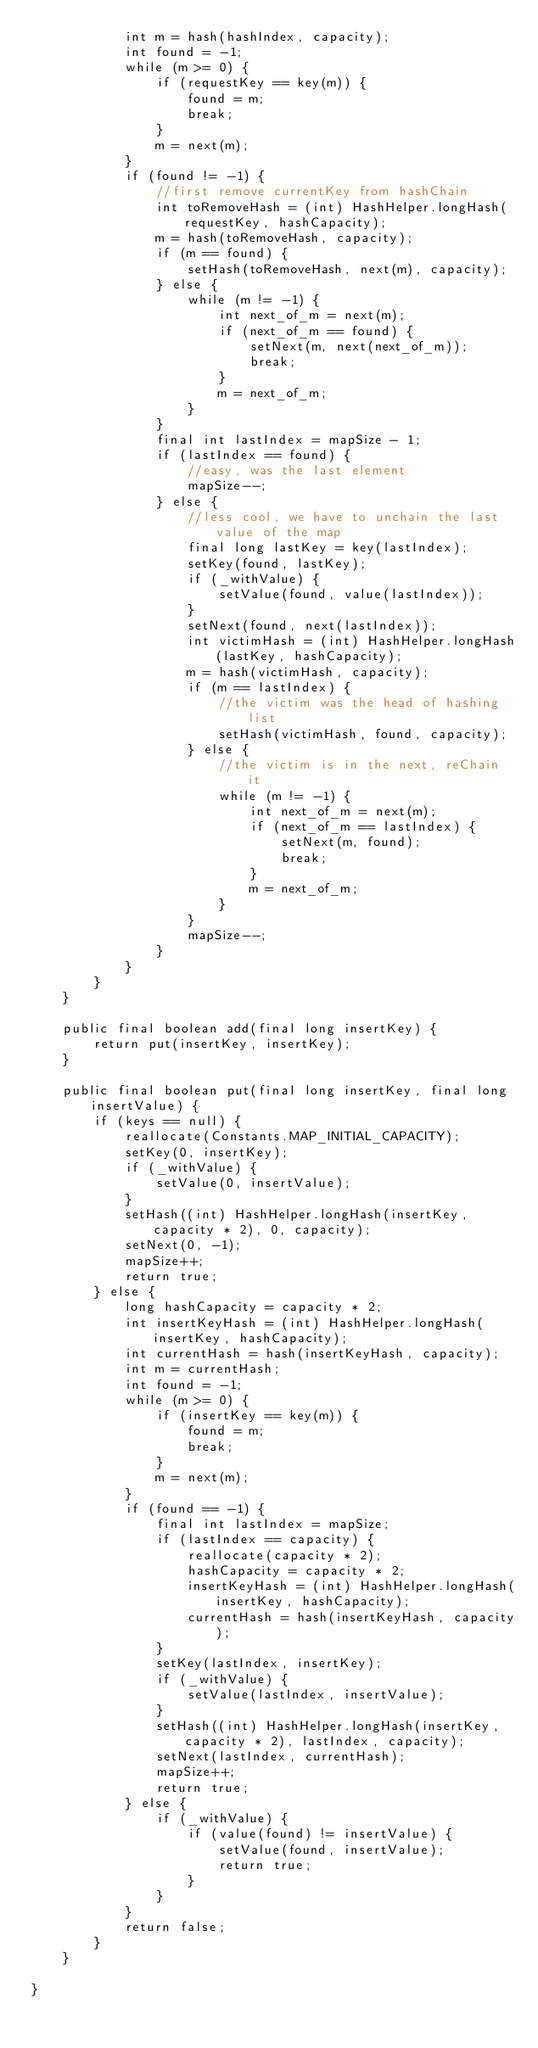<code> <loc_0><loc_0><loc_500><loc_500><_Java_>            int m = hash(hashIndex, capacity);
            int found = -1;
            while (m >= 0) {
                if (requestKey == key(m)) {
                    found = m;
                    break;
                }
                m = next(m);
            }
            if (found != -1) {
                //first remove currentKey from hashChain
                int toRemoveHash = (int) HashHelper.longHash(requestKey, hashCapacity);
                m = hash(toRemoveHash, capacity);
                if (m == found) {
                    setHash(toRemoveHash, next(m), capacity);
                } else {
                    while (m != -1) {
                        int next_of_m = next(m);
                        if (next_of_m == found) {
                            setNext(m, next(next_of_m));
                            break;
                        }
                        m = next_of_m;
                    }
                }
                final int lastIndex = mapSize - 1;
                if (lastIndex == found) {
                    //easy, was the last element
                    mapSize--;
                } else {
                    //less cool, we have to unchain the last value of the map
                    final long lastKey = key(lastIndex);
                    setKey(found, lastKey);
                    if (_withValue) {
                        setValue(found, value(lastIndex));
                    }
                    setNext(found, next(lastIndex));
                    int victimHash = (int) HashHelper.longHash(lastKey, hashCapacity);
                    m = hash(victimHash, capacity);
                    if (m == lastIndex) {
                        //the victim was the head of hashing list
                        setHash(victimHash, found, capacity);
                    } else {
                        //the victim is in the next, reChain it
                        while (m != -1) {
                            int next_of_m = next(m);
                            if (next_of_m == lastIndex) {
                                setNext(m, found);
                                break;
                            }
                            m = next_of_m;
                        }
                    }
                    mapSize--;
                }
            }
        }
    }

    public final boolean add(final long insertKey) {
        return put(insertKey, insertKey);
    }

    public final boolean put(final long insertKey, final long insertValue) {
        if (keys == null) {
            reallocate(Constants.MAP_INITIAL_CAPACITY);
            setKey(0, insertKey);
            if (_withValue) {
                setValue(0, insertValue);
            }
            setHash((int) HashHelper.longHash(insertKey, capacity * 2), 0, capacity);
            setNext(0, -1);
            mapSize++;
            return true;
        } else {
            long hashCapacity = capacity * 2;
            int insertKeyHash = (int) HashHelper.longHash(insertKey, hashCapacity);
            int currentHash = hash(insertKeyHash, capacity);
            int m = currentHash;
            int found = -1;
            while (m >= 0) {
                if (insertKey == key(m)) {
                    found = m;
                    break;
                }
                m = next(m);
            }
            if (found == -1) {
                final int lastIndex = mapSize;
                if (lastIndex == capacity) {
                    reallocate(capacity * 2);
                    hashCapacity = capacity * 2;
                    insertKeyHash = (int) HashHelper.longHash(insertKey, hashCapacity);
                    currentHash = hash(insertKeyHash, capacity);
                }
                setKey(lastIndex, insertKey);
                if (_withValue) {
                    setValue(lastIndex, insertValue);
                }
                setHash((int) HashHelper.longHash(insertKey, capacity * 2), lastIndex, capacity);
                setNext(lastIndex, currentHash);
                mapSize++;
                return true;
            } else {
                if (_withValue) {
                    if (value(found) != insertValue) {
                        setValue(found, insertValue);
                        return true;
                    }
                }
            }
            return false;
        }
    }

}
</code> 